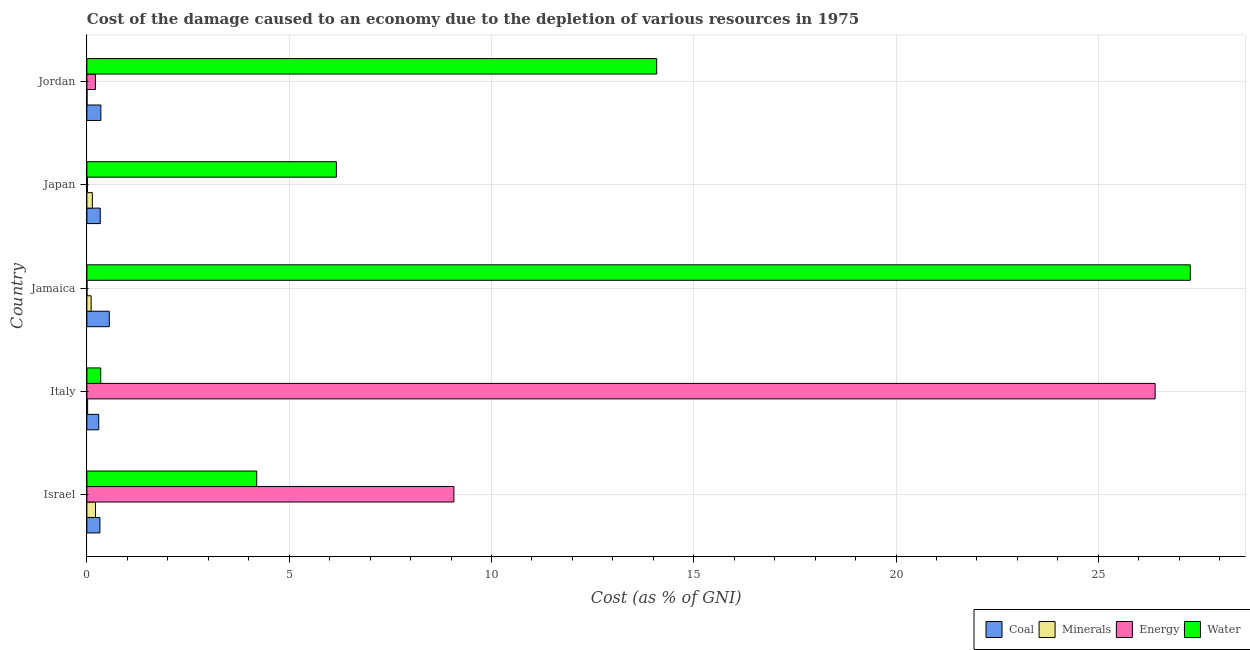Are the number of bars per tick equal to the number of legend labels?
Provide a succinct answer. Yes. How many bars are there on the 2nd tick from the bottom?
Offer a very short reply. 4. What is the label of the 5th group of bars from the top?
Make the answer very short. Israel. What is the cost of damage due to depletion of energy in Italy?
Provide a succinct answer. 26.4. Across all countries, what is the maximum cost of damage due to depletion of coal?
Offer a very short reply. 0.55. Across all countries, what is the minimum cost of damage due to depletion of water?
Your response must be concise. 0.34. In which country was the cost of damage due to depletion of coal maximum?
Offer a terse response. Jamaica. In which country was the cost of damage due to depletion of coal minimum?
Offer a very short reply. Italy. What is the total cost of damage due to depletion of water in the graph?
Ensure brevity in your answer.  52.06. What is the difference between the cost of damage due to depletion of energy in Israel and that in Jamaica?
Keep it short and to the point. 9.07. What is the difference between the cost of damage due to depletion of energy in Jordan and the cost of damage due to depletion of coal in Italy?
Your response must be concise. -0.08. What is the average cost of damage due to depletion of water per country?
Your answer should be very brief. 10.41. What is the difference between the cost of damage due to depletion of energy and cost of damage due to depletion of water in Jordan?
Offer a very short reply. -13.87. In how many countries, is the cost of damage due to depletion of energy greater than 23 %?
Your response must be concise. 1. What is the ratio of the cost of damage due to depletion of water in Italy to that in Japan?
Keep it short and to the point. 0.06. What is the difference between the highest and the second highest cost of damage due to depletion of coal?
Provide a succinct answer. 0.21. What is the difference between the highest and the lowest cost of damage due to depletion of coal?
Offer a very short reply. 0.26. Is it the case that in every country, the sum of the cost of damage due to depletion of coal and cost of damage due to depletion of water is greater than the sum of cost of damage due to depletion of energy and cost of damage due to depletion of minerals?
Your response must be concise. Yes. What does the 2nd bar from the top in Japan represents?
Your response must be concise. Energy. What does the 2nd bar from the bottom in Israel represents?
Provide a short and direct response. Minerals. Are all the bars in the graph horizontal?
Make the answer very short. Yes. How many countries are there in the graph?
Your answer should be compact. 5. How are the legend labels stacked?
Ensure brevity in your answer.  Horizontal. What is the title of the graph?
Keep it short and to the point. Cost of the damage caused to an economy due to the depletion of various resources in 1975 . What is the label or title of the X-axis?
Keep it short and to the point. Cost (as % of GNI). What is the label or title of the Y-axis?
Ensure brevity in your answer.  Country. What is the Cost (as % of GNI) in Coal in Israel?
Your response must be concise. 0.32. What is the Cost (as % of GNI) in Minerals in Israel?
Provide a short and direct response. 0.21. What is the Cost (as % of GNI) of Energy in Israel?
Make the answer very short. 9.07. What is the Cost (as % of GNI) of Water in Israel?
Provide a succinct answer. 4.2. What is the Cost (as % of GNI) in Coal in Italy?
Ensure brevity in your answer.  0.29. What is the Cost (as % of GNI) in Minerals in Italy?
Your answer should be very brief. 0.02. What is the Cost (as % of GNI) of Energy in Italy?
Keep it short and to the point. 26.4. What is the Cost (as % of GNI) of Water in Italy?
Offer a very short reply. 0.34. What is the Cost (as % of GNI) in Coal in Jamaica?
Offer a very short reply. 0.55. What is the Cost (as % of GNI) in Minerals in Jamaica?
Your answer should be very brief. 0.11. What is the Cost (as % of GNI) in Energy in Jamaica?
Keep it short and to the point. 0. What is the Cost (as % of GNI) in Water in Jamaica?
Provide a succinct answer. 27.27. What is the Cost (as % of GNI) in Coal in Japan?
Your answer should be compact. 0.33. What is the Cost (as % of GNI) in Minerals in Japan?
Provide a succinct answer. 0.13. What is the Cost (as % of GNI) of Energy in Japan?
Keep it short and to the point. 0.01. What is the Cost (as % of GNI) of Water in Japan?
Offer a very short reply. 6.17. What is the Cost (as % of GNI) in Coal in Jordan?
Provide a succinct answer. 0.35. What is the Cost (as % of GNI) in Minerals in Jordan?
Offer a terse response. 0. What is the Cost (as % of GNI) in Energy in Jordan?
Provide a short and direct response. 0.21. What is the Cost (as % of GNI) of Water in Jordan?
Make the answer very short. 14.08. Across all countries, what is the maximum Cost (as % of GNI) of Coal?
Make the answer very short. 0.55. Across all countries, what is the maximum Cost (as % of GNI) in Minerals?
Offer a terse response. 0.21. Across all countries, what is the maximum Cost (as % of GNI) of Energy?
Give a very brief answer. 26.4. Across all countries, what is the maximum Cost (as % of GNI) of Water?
Your answer should be compact. 27.27. Across all countries, what is the minimum Cost (as % of GNI) in Coal?
Offer a terse response. 0.29. Across all countries, what is the minimum Cost (as % of GNI) in Minerals?
Offer a very short reply. 0. Across all countries, what is the minimum Cost (as % of GNI) of Energy?
Your response must be concise. 0. Across all countries, what is the minimum Cost (as % of GNI) of Water?
Offer a terse response. 0.34. What is the total Cost (as % of GNI) of Coal in the graph?
Offer a very short reply. 1.84. What is the total Cost (as % of GNI) in Minerals in the graph?
Ensure brevity in your answer.  0.47. What is the total Cost (as % of GNI) of Energy in the graph?
Your response must be concise. 35.7. What is the total Cost (as % of GNI) in Water in the graph?
Make the answer very short. 52.06. What is the difference between the Cost (as % of GNI) in Coal in Israel and that in Italy?
Make the answer very short. 0.03. What is the difference between the Cost (as % of GNI) in Minerals in Israel and that in Italy?
Your answer should be compact. 0.2. What is the difference between the Cost (as % of GNI) in Energy in Israel and that in Italy?
Give a very brief answer. -17.33. What is the difference between the Cost (as % of GNI) in Water in Israel and that in Italy?
Give a very brief answer. 3.86. What is the difference between the Cost (as % of GNI) in Coal in Israel and that in Jamaica?
Give a very brief answer. -0.23. What is the difference between the Cost (as % of GNI) in Minerals in Israel and that in Jamaica?
Ensure brevity in your answer.  0.11. What is the difference between the Cost (as % of GNI) of Energy in Israel and that in Jamaica?
Make the answer very short. 9.07. What is the difference between the Cost (as % of GNI) of Water in Israel and that in Jamaica?
Offer a very short reply. -23.08. What is the difference between the Cost (as % of GNI) in Coal in Israel and that in Japan?
Provide a short and direct response. -0.01. What is the difference between the Cost (as % of GNI) in Minerals in Israel and that in Japan?
Ensure brevity in your answer.  0.08. What is the difference between the Cost (as % of GNI) of Energy in Israel and that in Japan?
Your response must be concise. 9.06. What is the difference between the Cost (as % of GNI) in Water in Israel and that in Japan?
Your response must be concise. -1.97. What is the difference between the Cost (as % of GNI) in Coal in Israel and that in Jordan?
Your answer should be very brief. -0.02. What is the difference between the Cost (as % of GNI) in Minerals in Israel and that in Jordan?
Ensure brevity in your answer.  0.21. What is the difference between the Cost (as % of GNI) in Energy in Israel and that in Jordan?
Keep it short and to the point. 8.86. What is the difference between the Cost (as % of GNI) of Water in Israel and that in Jordan?
Your answer should be very brief. -9.89. What is the difference between the Cost (as % of GNI) of Coal in Italy and that in Jamaica?
Ensure brevity in your answer.  -0.26. What is the difference between the Cost (as % of GNI) of Minerals in Italy and that in Jamaica?
Your answer should be very brief. -0.09. What is the difference between the Cost (as % of GNI) in Energy in Italy and that in Jamaica?
Offer a terse response. 26.4. What is the difference between the Cost (as % of GNI) of Water in Italy and that in Jamaica?
Provide a succinct answer. -26.93. What is the difference between the Cost (as % of GNI) of Coal in Italy and that in Japan?
Provide a succinct answer. -0.04. What is the difference between the Cost (as % of GNI) of Minerals in Italy and that in Japan?
Ensure brevity in your answer.  -0.12. What is the difference between the Cost (as % of GNI) of Energy in Italy and that in Japan?
Offer a very short reply. 26.39. What is the difference between the Cost (as % of GNI) in Water in Italy and that in Japan?
Provide a short and direct response. -5.82. What is the difference between the Cost (as % of GNI) of Coal in Italy and that in Jordan?
Your answer should be compact. -0.05. What is the difference between the Cost (as % of GNI) of Minerals in Italy and that in Jordan?
Offer a terse response. 0.02. What is the difference between the Cost (as % of GNI) in Energy in Italy and that in Jordan?
Your answer should be compact. 26.19. What is the difference between the Cost (as % of GNI) in Water in Italy and that in Jordan?
Keep it short and to the point. -13.74. What is the difference between the Cost (as % of GNI) in Coal in Jamaica and that in Japan?
Your answer should be very brief. 0.22. What is the difference between the Cost (as % of GNI) in Minerals in Jamaica and that in Japan?
Offer a terse response. -0.03. What is the difference between the Cost (as % of GNI) in Energy in Jamaica and that in Japan?
Offer a terse response. -0.01. What is the difference between the Cost (as % of GNI) in Water in Jamaica and that in Japan?
Make the answer very short. 21.11. What is the difference between the Cost (as % of GNI) in Coal in Jamaica and that in Jordan?
Make the answer very short. 0.21. What is the difference between the Cost (as % of GNI) of Minerals in Jamaica and that in Jordan?
Your answer should be compact. 0.1. What is the difference between the Cost (as % of GNI) of Energy in Jamaica and that in Jordan?
Your response must be concise. -0.21. What is the difference between the Cost (as % of GNI) of Water in Jamaica and that in Jordan?
Make the answer very short. 13.19. What is the difference between the Cost (as % of GNI) of Coal in Japan and that in Jordan?
Your answer should be very brief. -0.01. What is the difference between the Cost (as % of GNI) in Minerals in Japan and that in Jordan?
Give a very brief answer. 0.13. What is the difference between the Cost (as % of GNI) of Energy in Japan and that in Jordan?
Offer a terse response. -0.2. What is the difference between the Cost (as % of GNI) of Water in Japan and that in Jordan?
Offer a terse response. -7.92. What is the difference between the Cost (as % of GNI) in Coal in Israel and the Cost (as % of GNI) in Minerals in Italy?
Make the answer very short. 0.3. What is the difference between the Cost (as % of GNI) in Coal in Israel and the Cost (as % of GNI) in Energy in Italy?
Offer a terse response. -26.08. What is the difference between the Cost (as % of GNI) of Coal in Israel and the Cost (as % of GNI) of Water in Italy?
Provide a succinct answer. -0.02. What is the difference between the Cost (as % of GNI) in Minerals in Israel and the Cost (as % of GNI) in Energy in Italy?
Your response must be concise. -26.19. What is the difference between the Cost (as % of GNI) in Minerals in Israel and the Cost (as % of GNI) in Water in Italy?
Keep it short and to the point. -0.13. What is the difference between the Cost (as % of GNI) of Energy in Israel and the Cost (as % of GNI) of Water in Italy?
Ensure brevity in your answer.  8.73. What is the difference between the Cost (as % of GNI) in Coal in Israel and the Cost (as % of GNI) in Minerals in Jamaica?
Give a very brief answer. 0.22. What is the difference between the Cost (as % of GNI) in Coal in Israel and the Cost (as % of GNI) in Energy in Jamaica?
Ensure brevity in your answer.  0.32. What is the difference between the Cost (as % of GNI) in Coal in Israel and the Cost (as % of GNI) in Water in Jamaica?
Ensure brevity in your answer.  -26.95. What is the difference between the Cost (as % of GNI) in Minerals in Israel and the Cost (as % of GNI) in Energy in Jamaica?
Offer a terse response. 0.21. What is the difference between the Cost (as % of GNI) of Minerals in Israel and the Cost (as % of GNI) of Water in Jamaica?
Provide a succinct answer. -27.06. What is the difference between the Cost (as % of GNI) of Energy in Israel and the Cost (as % of GNI) of Water in Jamaica?
Make the answer very short. -18.2. What is the difference between the Cost (as % of GNI) in Coal in Israel and the Cost (as % of GNI) in Minerals in Japan?
Provide a short and direct response. 0.19. What is the difference between the Cost (as % of GNI) of Coal in Israel and the Cost (as % of GNI) of Energy in Japan?
Offer a terse response. 0.31. What is the difference between the Cost (as % of GNI) of Coal in Israel and the Cost (as % of GNI) of Water in Japan?
Your answer should be very brief. -5.84. What is the difference between the Cost (as % of GNI) of Minerals in Israel and the Cost (as % of GNI) of Energy in Japan?
Ensure brevity in your answer.  0.2. What is the difference between the Cost (as % of GNI) in Minerals in Israel and the Cost (as % of GNI) in Water in Japan?
Ensure brevity in your answer.  -5.95. What is the difference between the Cost (as % of GNI) in Energy in Israel and the Cost (as % of GNI) in Water in Japan?
Your answer should be very brief. 2.9. What is the difference between the Cost (as % of GNI) of Coal in Israel and the Cost (as % of GNI) of Minerals in Jordan?
Provide a succinct answer. 0.32. What is the difference between the Cost (as % of GNI) of Coal in Israel and the Cost (as % of GNI) of Energy in Jordan?
Make the answer very short. 0.11. What is the difference between the Cost (as % of GNI) in Coal in Israel and the Cost (as % of GNI) in Water in Jordan?
Offer a very short reply. -13.76. What is the difference between the Cost (as % of GNI) of Minerals in Israel and the Cost (as % of GNI) of Energy in Jordan?
Offer a very short reply. 0. What is the difference between the Cost (as % of GNI) in Minerals in Israel and the Cost (as % of GNI) in Water in Jordan?
Ensure brevity in your answer.  -13.87. What is the difference between the Cost (as % of GNI) of Energy in Israel and the Cost (as % of GNI) of Water in Jordan?
Ensure brevity in your answer.  -5.01. What is the difference between the Cost (as % of GNI) of Coal in Italy and the Cost (as % of GNI) of Minerals in Jamaica?
Your answer should be very brief. 0.19. What is the difference between the Cost (as % of GNI) in Coal in Italy and the Cost (as % of GNI) in Energy in Jamaica?
Make the answer very short. 0.29. What is the difference between the Cost (as % of GNI) in Coal in Italy and the Cost (as % of GNI) in Water in Jamaica?
Offer a terse response. -26.98. What is the difference between the Cost (as % of GNI) in Minerals in Italy and the Cost (as % of GNI) in Energy in Jamaica?
Give a very brief answer. 0.02. What is the difference between the Cost (as % of GNI) in Minerals in Italy and the Cost (as % of GNI) in Water in Jamaica?
Ensure brevity in your answer.  -27.25. What is the difference between the Cost (as % of GNI) of Energy in Italy and the Cost (as % of GNI) of Water in Jamaica?
Provide a short and direct response. -0.87. What is the difference between the Cost (as % of GNI) of Coal in Italy and the Cost (as % of GNI) of Minerals in Japan?
Provide a short and direct response. 0.16. What is the difference between the Cost (as % of GNI) of Coal in Italy and the Cost (as % of GNI) of Energy in Japan?
Provide a short and direct response. 0.28. What is the difference between the Cost (as % of GNI) in Coal in Italy and the Cost (as % of GNI) in Water in Japan?
Give a very brief answer. -5.87. What is the difference between the Cost (as % of GNI) in Minerals in Italy and the Cost (as % of GNI) in Energy in Japan?
Ensure brevity in your answer.  0.01. What is the difference between the Cost (as % of GNI) of Minerals in Italy and the Cost (as % of GNI) of Water in Japan?
Your answer should be very brief. -6.15. What is the difference between the Cost (as % of GNI) in Energy in Italy and the Cost (as % of GNI) in Water in Japan?
Your response must be concise. 20.24. What is the difference between the Cost (as % of GNI) in Coal in Italy and the Cost (as % of GNI) in Minerals in Jordan?
Give a very brief answer. 0.29. What is the difference between the Cost (as % of GNI) of Coal in Italy and the Cost (as % of GNI) of Energy in Jordan?
Your response must be concise. 0.08. What is the difference between the Cost (as % of GNI) in Coal in Italy and the Cost (as % of GNI) in Water in Jordan?
Make the answer very short. -13.79. What is the difference between the Cost (as % of GNI) of Minerals in Italy and the Cost (as % of GNI) of Energy in Jordan?
Offer a very short reply. -0.19. What is the difference between the Cost (as % of GNI) of Minerals in Italy and the Cost (as % of GNI) of Water in Jordan?
Make the answer very short. -14.07. What is the difference between the Cost (as % of GNI) of Energy in Italy and the Cost (as % of GNI) of Water in Jordan?
Your answer should be compact. 12.32. What is the difference between the Cost (as % of GNI) of Coal in Jamaica and the Cost (as % of GNI) of Minerals in Japan?
Make the answer very short. 0.42. What is the difference between the Cost (as % of GNI) of Coal in Jamaica and the Cost (as % of GNI) of Energy in Japan?
Your answer should be very brief. 0.54. What is the difference between the Cost (as % of GNI) of Coal in Jamaica and the Cost (as % of GNI) of Water in Japan?
Make the answer very short. -5.61. What is the difference between the Cost (as % of GNI) in Minerals in Jamaica and the Cost (as % of GNI) in Energy in Japan?
Offer a terse response. 0.09. What is the difference between the Cost (as % of GNI) of Minerals in Jamaica and the Cost (as % of GNI) of Water in Japan?
Give a very brief answer. -6.06. What is the difference between the Cost (as % of GNI) in Energy in Jamaica and the Cost (as % of GNI) in Water in Japan?
Offer a very short reply. -6.16. What is the difference between the Cost (as % of GNI) in Coal in Jamaica and the Cost (as % of GNI) in Minerals in Jordan?
Give a very brief answer. 0.55. What is the difference between the Cost (as % of GNI) in Coal in Jamaica and the Cost (as % of GNI) in Energy in Jordan?
Provide a short and direct response. 0.34. What is the difference between the Cost (as % of GNI) in Coal in Jamaica and the Cost (as % of GNI) in Water in Jordan?
Your answer should be compact. -13.53. What is the difference between the Cost (as % of GNI) in Minerals in Jamaica and the Cost (as % of GNI) in Energy in Jordan?
Your answer should be compact. -0.11. What is the difference between the Cost (as % of GNI) of Minerals in Jamaica and the Cost (as % of GNI) of Water in Jordan?
Ensure brevity in your answer.  -13.98. What is the difference between the Cost (as % of GNI) in Energy in Jamaica and the Cost (as % of GNI) in Water in Jordan?
Give a very brief answer. -14.08. What is the difference between the Cost (as % of GNI) in Coal in Japan and the Cost (as % of GNI) in Minerals in Jordan?
Offer a terse response. 0.33. What is the difference between the Cost (as % of GNI) of Coal in Japan and the Cost (as % of GNI) of Energy in Jordan?
Keep it short and to the point. 0.12. What is the difference between the Cost (as % of GNI) in Coal in Japan and the Cost (as % of GNI) in Water in Jordan?
Offer a terse response. -13.75. What is the difference between the Cost (as % of GNI) in Minerals in Japan and the Cost (as % of GNI) in Energy in Jordan?
Your answer should be compact. -0.08. What is the difference between the Cost (as % of GNI) in Minerals in Japan and the Cost (as % of GNI) in Water in Jordan?
Your response must be concise. -13.95. What is the difference between the Cost (as % of GNI) in Energy in Japan and the Cost (as % of GNI) in Water in Jordan?
Your answer should be compact. -14.07. What is the average Cost (as % of GNI) of Coal per country?
Your answer should be compact. 0.37. What is the average Cost (as % of GNI) of Minerals per country?
Your response must be concise. 0.09. What is the average Cost (as % of GNI) of Energy per country?
Keep it short and to the point. 7.14. What is the average Cost (as % of GNI) of Water per country?
Your response must be concise. 10.41. What is the difference between the Cost (as % of GNI) in Coal and Cost (as % of GNI) in Minerals in Israel?
Ensure brevity in your answer.  0.11. What is the difference between the Cost (as % of GNI) of Coal and Cost (as % of GNI) of Energy in Israel?
Provide a succinct answer. -8.75. What is the difference between the Cost (as % of GNI) of Coal and Cost (as % of GNI) of Water in Israel?
Your answer should be very brief. -3.88. What is the difference between the Cost (as % of GNI) in Minerals and Cost (as % of GNI) in Energy in Israel?
Keep it short and to the point. -8.86. What is the difference between the Cost (as % of GNI) in Minerals and Cost (as % of GNI) in Water in Israel?
Provide a succinct answer. -3.98. What is the difference between the Cost (as % of GNI) of Energy and Cost (as % of GNI) of Water in Israel?
Provide a succinct answer. 4.87. What is the difference between the Cost (as % of GNI) in Coal and Cost (as % of GNI) in Minerals in Italy?
Your answer should be compact. 0.27. What is the difference between the Cost (as % of GNI) in Coal and Cost (as % of GNI) in Energy in Italy?
Your response must be concise. -26.11. What is the difference between the Cost (as % of GNI) in Coal and Cost (as % of GNI) in Water in Italy?
Give a very brief answer. -0.05. What is the difference between the Cost (as % of GNI) in Minerals and Cost (as % of GNI) in Energy in Italy?
Your response must be concise. -26.39. What is the difference between the Cost (as % of GNI) of Minerals and Cost (as % of GNI) of Water in Italy?
Offer a very short reply. -0.32. What is the difference between the Cost (as % of GNI) of Energy and Cost (as % of GNI) of Water in Italy?
Your response must be concise. 26.06. What is the difference between the Cost (as % of GNI) in Coal and Cost (as % of GNI) in Minerals in Jamaica?
Give a very brief answer. 0.45. What is the difference between the Cost (as % of GNI) in Coal and Cost (as % of GNI) in Energy in Jamaica?
Provide a short and direct response. 0.55. What is the difference between the Cost (as % of GNI) of Coal and Cost (as % of GNI) of Water in Jamaica?
Ensure brevity in your answer.  -26.72. What is the difference between the Cost (as % of GNI) of Minerals and Cost (as % of GNI) of Energy in Jamaica?
Your response must be concise. 0.1. What is the difference between the Cost (as % of GNI) in Minerals and Cost (as % of GNI) in Water in Jamaica?
Offer a very short reply. -27.17. What is the difference between the Cost (as % of GNI) of Energy and Cost (as % of GNI) of Water in Jamaica?
Your response must be concise. -27.27. What is the difference between the Cost (as % of GNI) of Coal and Cost (as % of GNI) of Minerals in Japan?
Keep it short and to the point. 0.2. What is the difference between the Cost (as % of GNI) of Coal and Cost (as % of GNI) of Energy in Japan?
Provide a short and direct response. 0.32. What is the difference between the Cost (as % of GNI) in Coal and Cost (as % of GNI) in Water in Japan?
Offer a terse response. -5.84. What is the difference between the Cost (as % of GNI) in Minerals and Cost (as % of GNI) in Energy in Japan?
Your answer should be compact. 0.12. What is the difference between the Cost (as % of GNI) in Minerals and Cost (as % of GNI) in Water in Japan?
Your answer should be very brief. -6.03. What is the difference between the Cost (as % of GNI) in Energy and Cost (as % of GNI) in Water in Japan?
Your answer should be compact. -6.15. What is the difference between the Cost (as % of GNI) of Coal and Cost (as % of GNI) of Minerals in Jordan?
Give a very brief answer. 0.34. What is the difference between the Cost (as % of GNI) of Coal and Cost (as % of GNI) of Energy in Jordan?
Provide a succinct answer. 0.14. What is the difference between the Cost (as % of GNI) of Coal and Cost (as % of GNI) of Water in Jordan?
Offer a very short reply. -13.74. What is the difference between the Cost (as % of GNI) in Minerals and Cost (as % of GNI) in Energy in Jordan?
Your response must be concise. -0.21. What is the difference between the Cost (as % of GNI) in Minerals and Cost (as % of GNI) in Water in Jordan?
Your response must be concise. -14.08. What is the difference between the Cost (as % of GNI) in Energy and Cost (as % of GNI) in Water in Jordan?
Provide a succinct answer. -13.87. What is the ratio of the Cost (as % of GNI) of Coal in Israel to that in Italy?
Make the answer very short. 1.1. What is the ratio of the Cost (as % of GNI) in Minerals in Israel to that in Italy?
Keep it short and to the point. 11.73. What is the ratio of the Cost (as % of GNI) of Energy in Israel to that in Italy?
Offer a very short reply. 0.34. What is the ratio of the Cost (as % of GNI) in Water in Israel to that in Italy?
Your response must be concise. 12.29. What is the ratio of the Cost (as % of GNI) of Coal in Israel to that in Jamaica?
Your answer should be very brief. 0.58. What is the ratio of the Cost (as % of GNI) in Minerals in Israel to that in Jamaica?
Give a very brief answer. 2.03. What is the ratio of the Cost (as % of GNI) in Energy in Israel to that in Jamaica?
Provide a succinct answer. 6405.7. What is the ratio of the Cost (as % of GNI) in Water in Israel to that in Jamaica?
Offer a very short reply. 0.15. What is the ratio of the Cost (as % of GNI) in Coal in Israel to that in Japan?
Offer a terse response. 0.97. What is the ratio of the Cost (as % of GNI) in Minerals in Israel to that in Japan?
Keep it short and to the point. 1.58. What is the ratio of the Cost (as % of GNI) in Energy in Israel to that in Japan?
Make the answer very short. 694.96. What is the ratio of the Cost (as % of GNI) of Water in Israel to that in Japan?
Your response must be concise. 0.68. What is the ratio of the Cost (as % of GNI) of Coal in Israel to that in Jordan?
Make the answer very short. 0.93. What is the ratio of the Cost (as % of GNI) in Minerals in Israel to that in Jordan?
Provide a short and direct response. 99.31. What is the ratio of the Cost (as % of GNI) of Energy in Israel to that in Jordan?
Give a very brief answer. 43.12. What is the ratio of the Cost (as % of GNI) in Water in Israel to that in Jordan?
Provide a short and direct response. 0.3. What is the ratio of the Cost (as % of GNI) in Coal in Italy to that in Jamaica?
Your answer should be very brief. 0.53. What is the ratio of the Cost (as % of GNI) in Minerals in Italy to that in Jamaica?
Provide a short and direct response. 0.17. What is the ratio of the Cost (as % of GNI) in Energy in Italy to that in Jamaica?
Make the answer very short. 1.86e+04. What is the ratio of the Cost (as % of GNI) in Water in Italy to that in Jamaica?
Offer a very short reply. 0.01. What is the ratio of the Cost (as % of GNI) of Coal in Italy to that in Japan?
Make the answer very short. 0.89. What is the ratio of the Cost (as % of GNI) of Minerals in Italy to that in Japan?
Your answer should be compact. 0.13. What is the ratio of the Cost (as % of GNI) in Energy in Italy to that in Japan?
Offer a terse response. 2022.97. What is the ratio of the Cost (as % of GNI) of Water in Italy to that in Japan?
Your answer should be very brief. 0.06. What is the ratio of the Cost (as % of GNI) in Coal in Italy to that in Jordan?
Make the answer very short. 0.85. What is the ratio of the Cost (as % of GNI) of Minerals in Italy to that in Jordan?
Offer a terse response. 8.46. What is the ratio of the Cost (as % of GNI) in Energy in Italy to that in Jordan?
Your response must be concise. 125.51. What is the ratio of the Cost (as % of GNI) in Water in Italy to that in Jordan?
Give a very brief answer. 0.02. What is the ratio of the Cost (as % of GNI) of Coal in Jamaica to that in Japan?
Give a very brief answer. 1.67. What is the ratio of the Cost (as % of GNI) of Minerals in Jamaica to that in Japan?
Keep it short and to the point. 0.78. What is the ratio of the Cost (as % of GNI) in Energy in Jamaica to that in Japan?
Make the answer very short. 0.11. What is the ratio of the Cost (as % of GNI) in Water in Jamaica to that in Japan?
Your answer should be compact. 4.42. What is the ratio of the Cost (as % of GNI) in Coal in Jamaica to that in Jordan?
Ensure brevity in your answer.  1.6. What is the ratio of the Cost (as % of GNI) in Minerals in Jamaica to that in Jordan?
Ensure brevity in your answer.  48.97. What is the ratio of the Cost (as % of GNI) in Energy in Jamaica to that in Jordan?
Offer a terse response. 0.01. What is the ratio of the Cost (as % of GNI) of Water in Jamaica to that in Jordan?
Ensure brevity in your answer.  1.94. What is the ratio of the Cost (as % of GNI) of Coal in Japan to that in Jordan?
Your answer should be very brief. 0.96. What is the ratio of the Cost (as % of GNI) of Minerals in Japan to that in Jordan?
Your answer should be compact. 62.86. What is the ratio of the Cost (as % of GNI) of Energy in Japan to that in Jordan?
Offer a terse response. 0.06. What is the ratio of the Cost (as % of GNI) of Water in Japan to that in Jordan?
Provide a short and direct response. 0.44. What is the difference between the highest and the second highest Cost (as % of GNI) of Coal?
Offer a very short reply. 0.21. What is the difference between the highest and the second highest Cost (as % of GNI) of Minerals?
Provide a short and direct response. 0.08. What is the difference between the highest and the second highest Cost (as % of GNI) of Energy?
Make the answer very short. 17.33. What is the difference between the highest and the second highest Cost (as % of GNI) in Water?
Your answer should be compact. 13.19. What is the difference between the highest and the lowest Cost (as % of GNI) of Coal?
Offer a terse response. 0.26. What is the difference between the highest and the lowest Cost (as % of GNI) in Minerals?
Your answer should be compact. 0.21. What is the difference between the highest and the lowest Cost (as % of GNI) in Energy?
Ensure brevity in your answer.  26.4. What is the difference between the highest and the lowest Cost (as % of GNI) in Water?
Your answer should be compact. 26.93. 